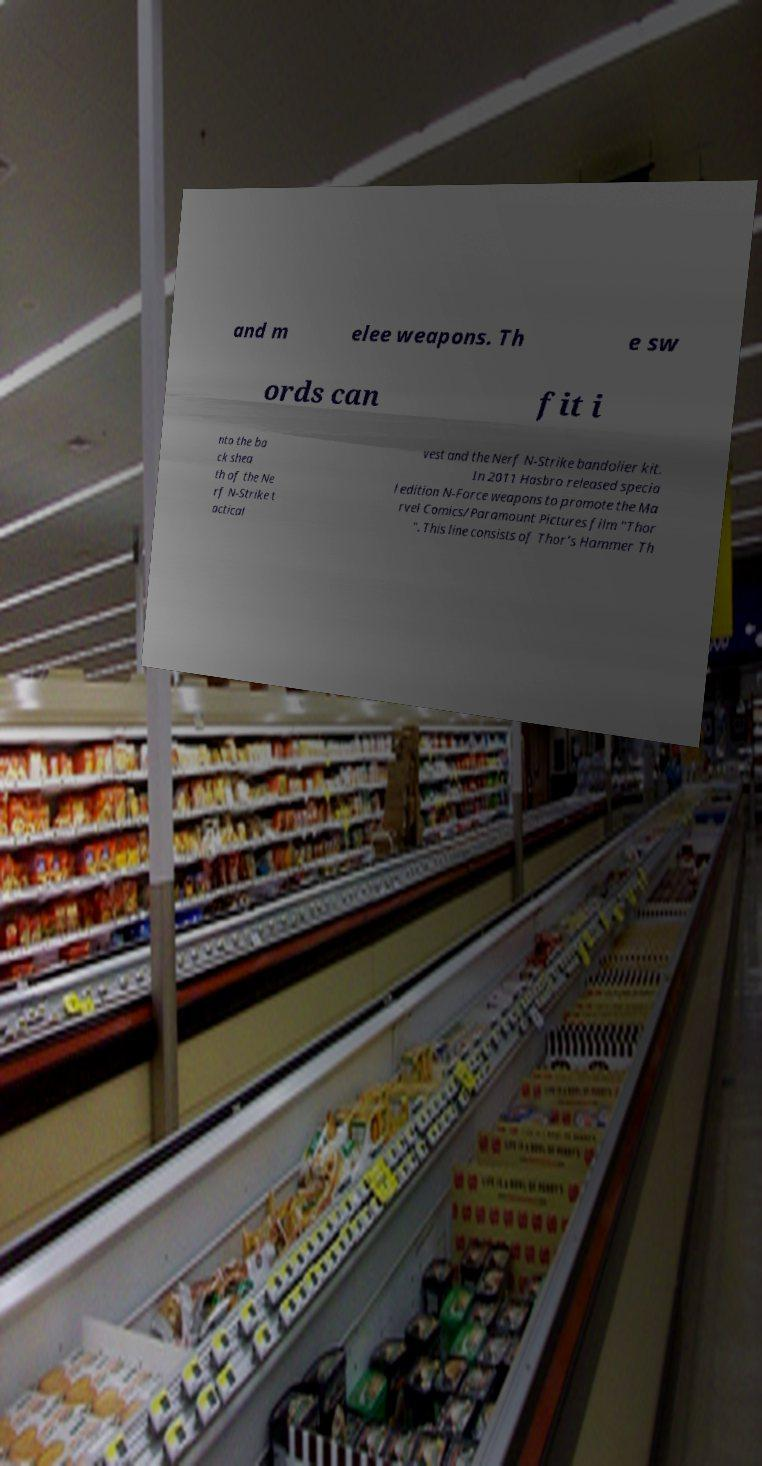I need the written content from this picture converted into text. Can you do that? and m elee weapons. Th e sw ords can fit i nto the ba ck shea th of the Ne rf N-Strike t actical vest and the Nerf N-Strike bandolier kit. In 2011 Hasbro released specia l edition N-Force weapons to promote the Ma rvel Comics/Paramount Pictures film "Thor ". This line consists of Thor's Hammer Th 